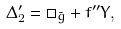<formula> <loc_0><loc_0><loc_500><loc_500>\Delta ^ { \prime } _ { 2 } = \Box _ { \tilde { g } } + f ^ { \prime \prime } Y ,</formula> 